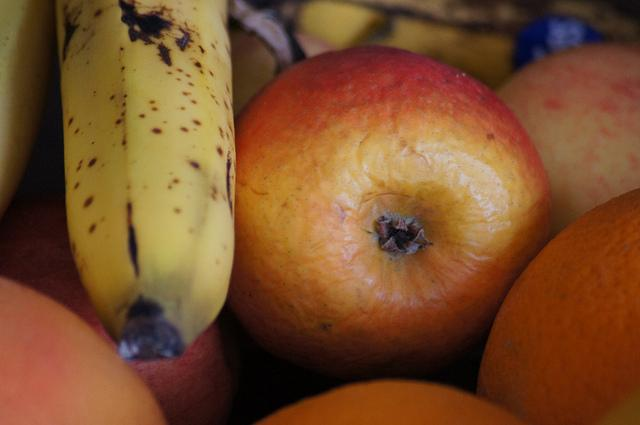What is the color of the fruit in the center of the pile?

Choices:
A) orange
B) purple
C) blue
D) red orange 